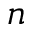Convert formula to latex. <formula><loc_0><loc_0><loc_500><loc_500>n</formula> 